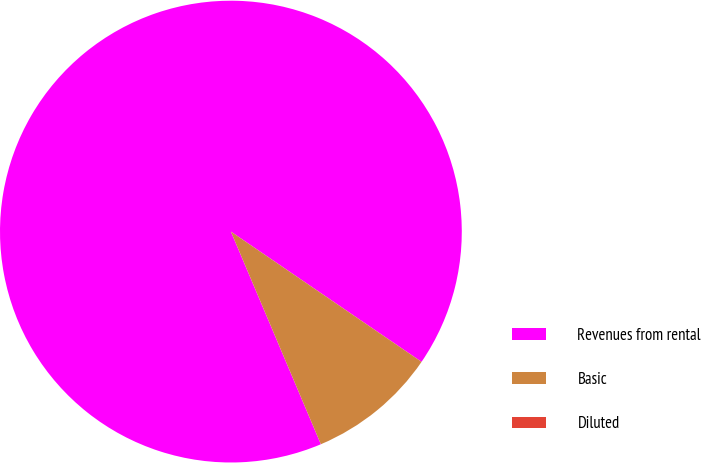Convert chart. <chart><loc_0><loc_0><loc_500><loc_500><pie_chart><fcel>Revenues from rental<fcel>Basic<fcel>Diluted<nl><fcel>90.91%<fcel>9.09%<fcel>0.0%<nl></chart> 